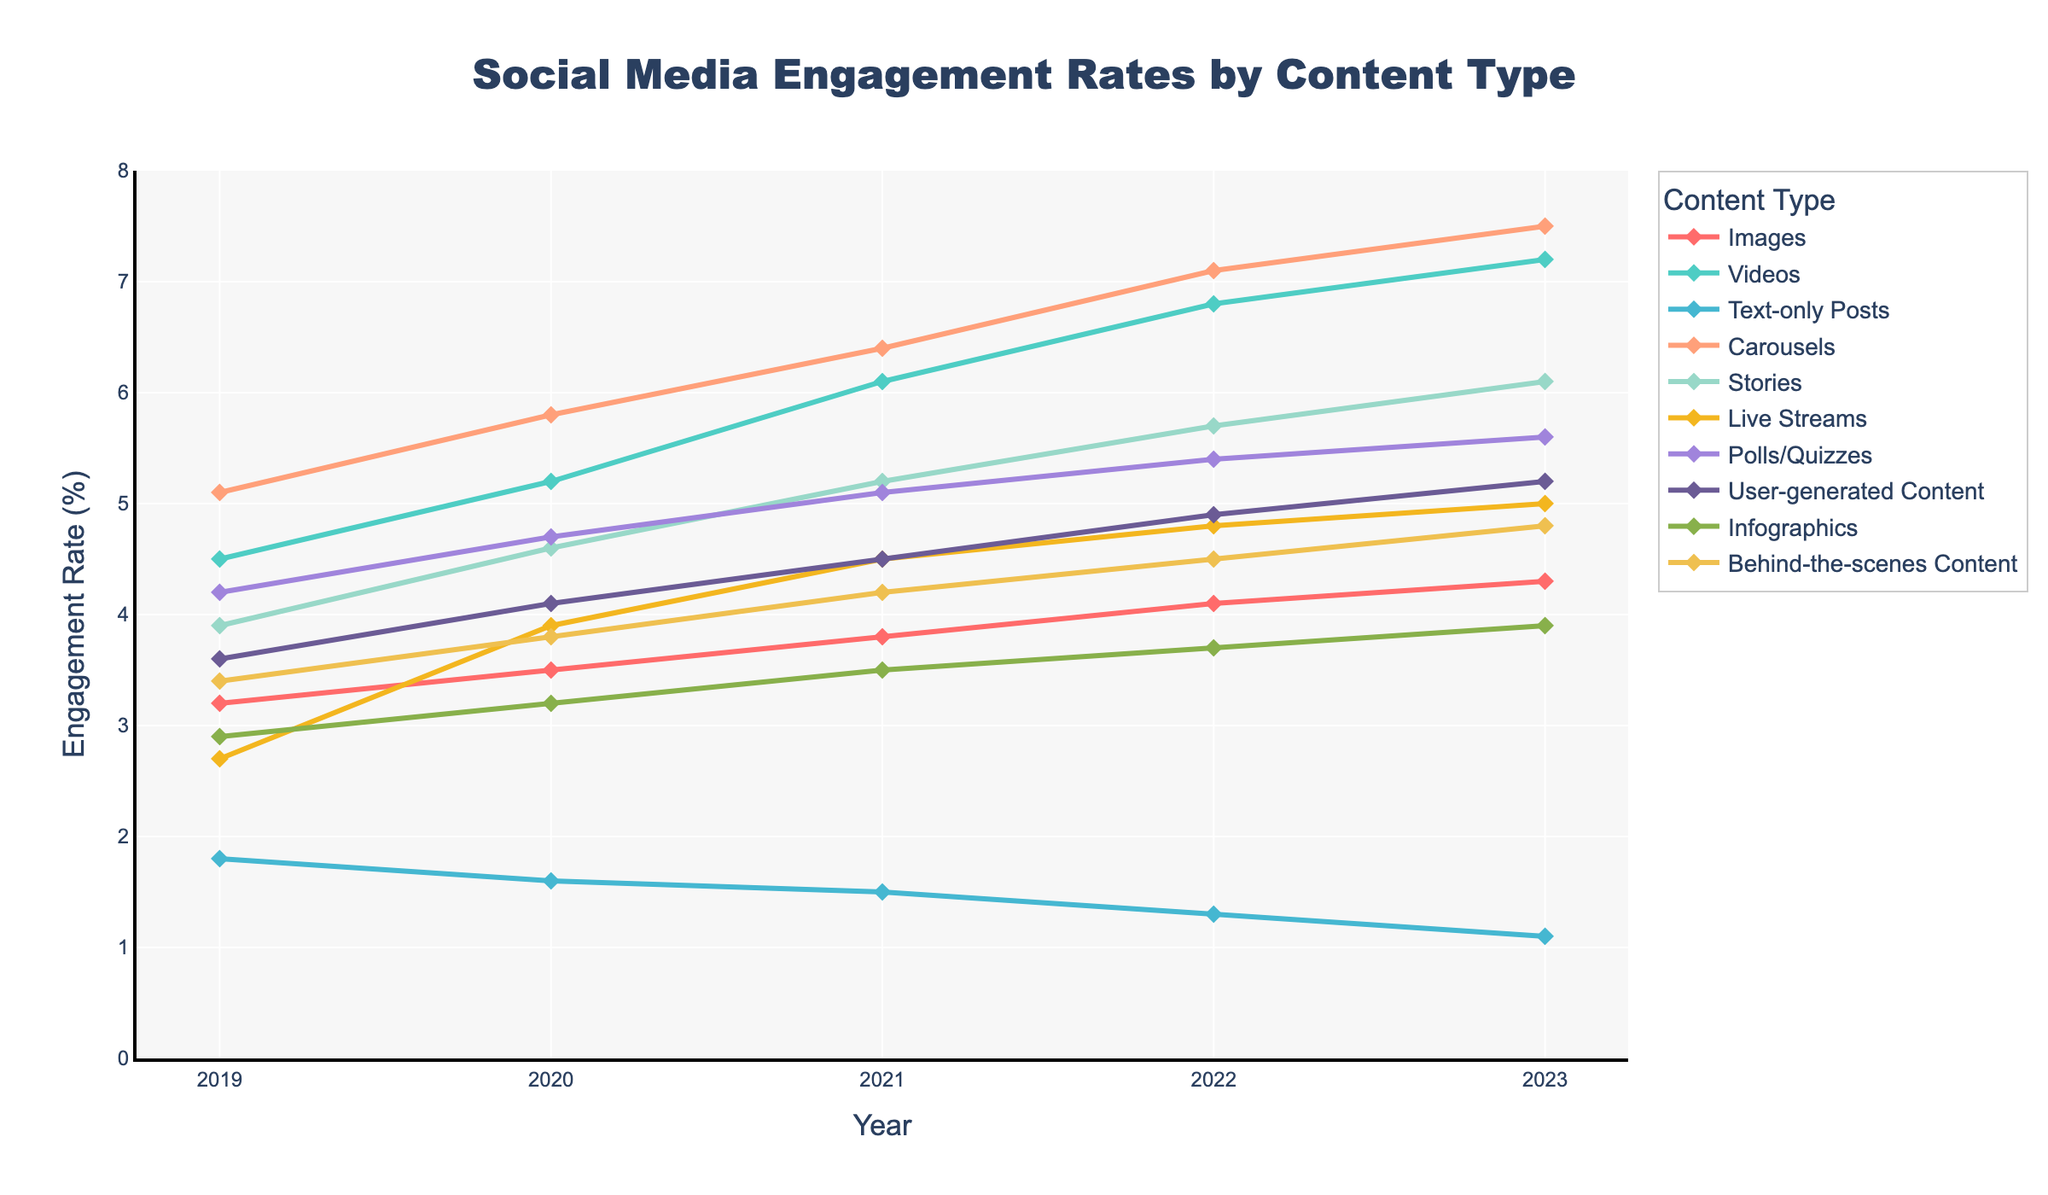Which content type had the highest engagement rate in 2023? To find the content type with the highest engagement rate in 2023, scan the engagement rates for all categories in that year. Carousels, with 7.5%, had the highest engagement rate.
Answer: Carousels How did the engagement rate for Live Streams change from 2019 to 2023? For Live Streams, compare the engagement rates from 2019 (2.7%) and 2023 (5.0%). The rate increased by 5.0 - 2.7 = 2.3%.
Answer: Increased by 2.3% Which content type had the largest overall increase in engagement rate from 2019 to 2023? Calculate the difference in engagement rates from 2019 to 2023 for all content types. Carousels had the largest increase, from 5.1% in 2019 to 7.5% in 2023, an increase of 2.4%.
Answer: Carousels What is the trend in engagement rates for Text-only Posts from 2019 to 2023? Observe the engagement rates for Text-only Posts from 2019 to 2023. The rates decrease each year: 1.8%, 1.6%, 1.5%, 1.3%, 1.1%.
Answer: Decreasing trend Did Videos or Stories have a higher engagement rate in 2020? Compare the engagement rates for Videos and Stories in 2020. Videos had a rate of 5.2% while Stories had 4.6%.
Answer: Videos Which content type shows a consistent increase in engagement rate every year from 2019 to 2023? Check the annual engagement rates for each content type. Videos, Stories, Carousels, and User-generated Content all show consistent annual increases.
Answer: Multiple: Videos, Stories, Carousels, User-generated Content Compare the average engagement rate of Images and Infographics over the five years (2019-2023). Which is higher? Calculate the average engagement rate for Images (sum: 3.2+3.5+3.8+4.1+4.3 = 18.9, average: 18.9/5 = 3.78) and Infographics (sum: 2.9+3.2+3.5+3.7+3.9 = 17.2, average: 17.2/5 = 3.44).
Answer: Higher for Images What is the difference in engagement rates between Carousels and User-generated Content in 2023? Look at the engagement rates for Carousels (7.5%) and User-generated Content (5.2%) in 2023 and calculate the difference: 7.5 - 5.2 = 2.3%.
Answer: 2.3% Between 2020 and 2023, which content type saw the smallest increase in engagement rate? Calculate the increase for each content type from 2020 to 2023. Text-only Posts had the smallest increase, decreasing by 1.6 - 1.1 = -0.5%.
Answer: Text-only Posts What color represents Polls/Quizzes on the chart? Look for the visual attribute color assigned to Polls/Quizzes. It is represented by the yellow color.
Answer: Yellow 